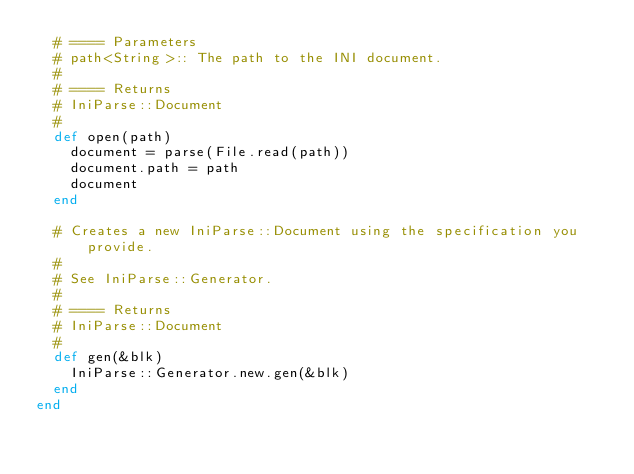Convert code to text. <code><loc_0><loc_0><loc_500><loc_500><_Ruby_>  # ==== Parameters
  # path<String>:: The path to the INI document.
  #
  # ==== Returns
  # IniParse::Document
  #
  def open(path)
    document = parse(File.read(path))
    document.path = path
    document
  end

  # Creates a new IniParse::Document using the specification you provide.
  #
  # See IniParse::Generator.
  #
  # ==== Returns
  # IniParse::Document
  #
  def gen(&blk)
    IniParse::Generator.new.gen(&blk)
  end
end
</code> 